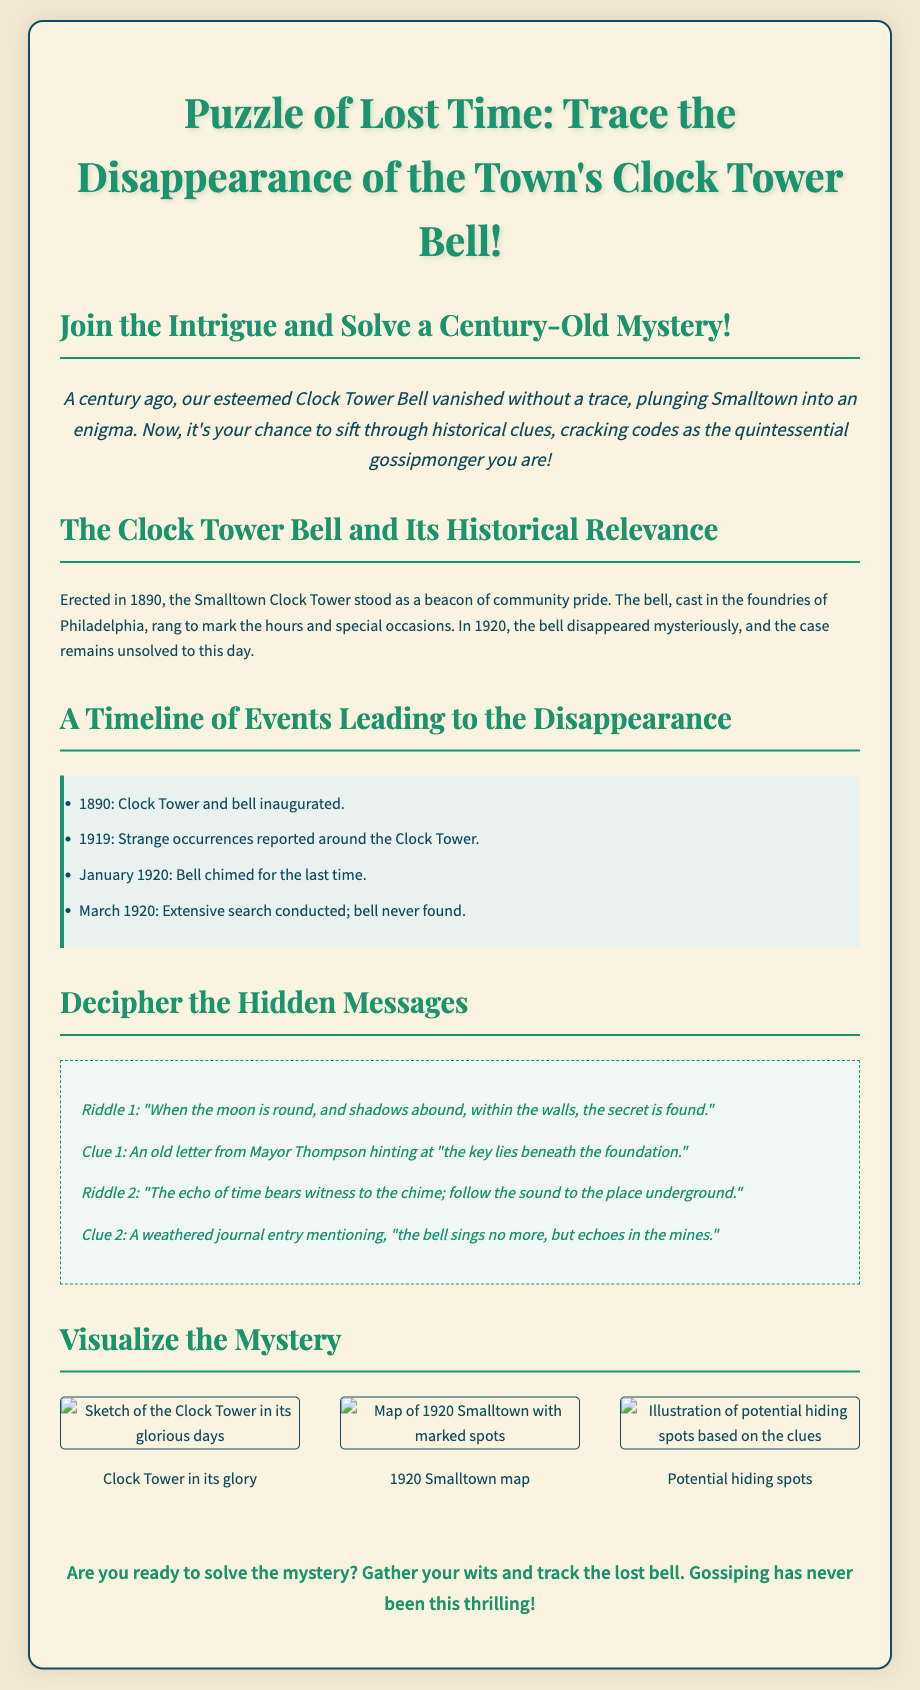What year was the Clock Tower erected? The document states that the Clock Tower was erected in 1890.
Answer: 1890 When did the bell chime for the last time? The timeline in the document indicates that the bell chimed for the last time in January 1920.
Answer: January 1920 What strange occurrences were reported around the Clock Tower? The document mentions "strange occurrences" but does not specify them, indicating the need for further inquiry.
Answer: Strange occurrences What was the Clue 1 from the riddles? Clue 1 is stated as "an old letter from Mayor Thompson hinting at 'the key lies beneath the foundation.'"
Answer: beneath the foundation Which city's foundries cast the bell? The document specifies that the bell was cast in the foundries of Philadelphia.
Answer: Philadelphia What is the focus of the "Puzzle of Lost Time"? The flyer emphasizes tracing the disappearance of the town's Clock Tower Bell.
Answer: disappearance of the Clock Tower Bell How many timelines of events are mentioned? The document lists four specific events leading to the disappearance.
Answer: Four What is described in the first riddle? The first riddle suggests finding a secret when the moon is round and shadows abound.
Answer: moon is round, shadows abound What type of visual aids are included in the flyer? The document contains sketches depicting the Clock Tower, a map of Smalltown, and potential hiding spots.
Answer: Sketches 